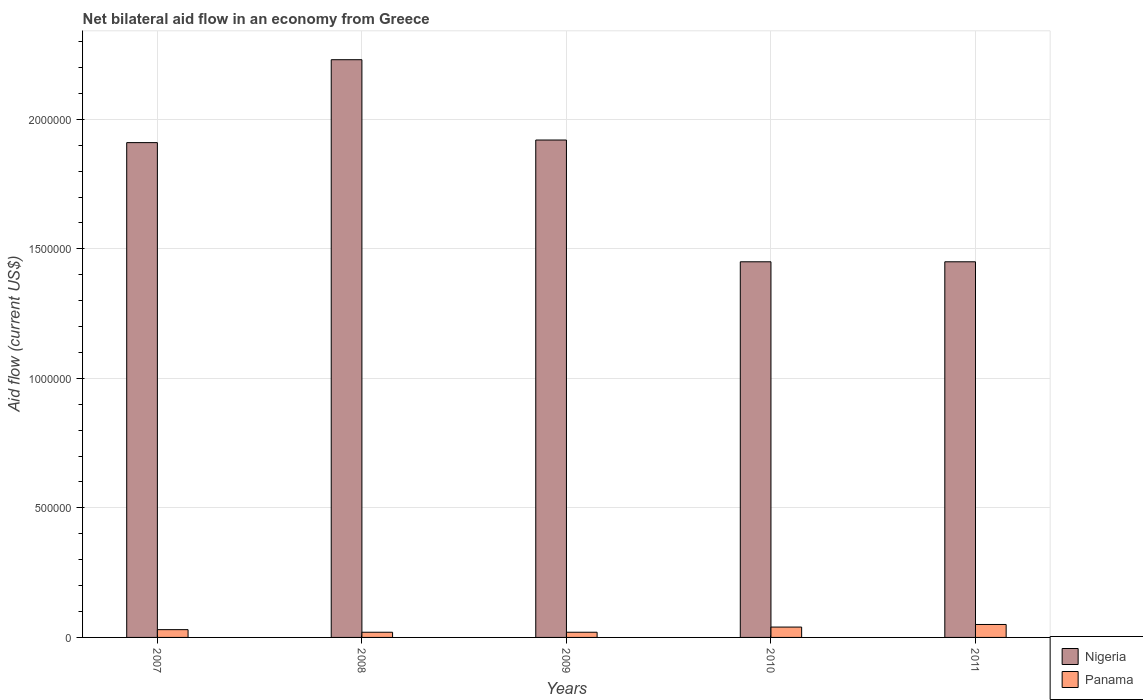How many different coloured bars are there?
Offer a very short reply. 2. How many groups of bars are there?
Keep it short and to the point. 5. Are the number of bars on each tick of the X-axis equal?
Provide a short and direct response. Yes. How many bars are there on the 4th tick from the right?
Your response must be concise. 2. What is the net bilateral aid flow in Nigeria in 2010?
Your response must be concise. 1.45e+06. Across all years, what is the maximum net bilateral aid flow in Panama?
Provide a short and direct response. 5.00e+04. Across all years, what is the minimum net bilateral aid flow in Nigeria?
Provide a short and direct response. 1.45e+06. What is the total net bilateral aid flow in Nigeria in the graph?
Keep it short and to the point. 8.96e+06. What is the difference between the net bilateral aid flow in Nigeria in 2007 and the net bilateral aid flow in Panama in 2009?
Make the answer very short. 1.89e+06. What is the average net bilateral aid flow in Nigeria per year?
Your answer should be very brief. 1.79e+06. In the year 2008, what is the difference between the net bilateral aid flow in Panama and net bilateral aid flow in Nigeria?
Make the answer very short. -2.21e+06. What is the ratio of the net bilateral aid flow in Nigeria in 2008 to that in 2009?
Provide a succinct answer. 1.16. Is the difference between the net bilateral aid flow in Panama in 2007 and 2008 greater than the difference between the net bilateral aid flow in Nigeria in 2007 and 2008?
Ensure brevity in your answer.  Yes. What is the difference between the highest and the second highest net bilateral aid flow in Panama?
Provide a short and direct response. 10000. Is the sum of the net bilateral aid flow in Panama in 2009 and 2011 greater than the maximum net bilateral aid flow in Nigeria across all years?
Offer a terse response. No. What does the 2nd bar from the left in 2007 represents?
Offer a very short reply. Panama. What does the 1st bar from the right in 2011 represents?
Provide a short and direct response. Panama. Are all the bars in the graph horizontal?
Provide a succinct answer. No. What is the difference between two consecutive major ticks on the Y-axis?
Make the answer very short. 5.00e+05. Are the values on the major ticks of Y-axis written in scientific E-notation?
Your answer should be compact. No. Where does the legend appear in the graph?
Your answer should be compact. Bottom right. How many legend labels are there?
Your response must be concise. 2. How are the legend labels stacked?
Keep it short and to the point. Vertical. What is the title of the graph?
Provide a succinct answer. Net bilateral aid flow in an economy from Greece. What is the label or title of the Y-axis?
Make the answer very short. Aid flow (current US$). What is the Aid flow (current US$) in Nigeria in 2007?
Your answer should be compact. 1.91e+06. What is the Aid flow (current US$) of Nigeria in 2008?
Offer a very short reply. 2.23e+06. What is the Aid flow (current US$) in Nigeria in 2009?
Keep it short and to the point. 1.92e+06. What is the Aid flow (current US$) in Nigeria in 2010?
Provide a succinct answer. 1.45e+06. What is the Aid flow (current US$) of Nigeria in 2011?
Your response must be concise. 1.45e+06. Across all years, what is the maximum Aid flow (current US$) in Nigeria?
Give a very brief answer. 2.23e+06. Across all years, what is the maximum Aid flow (current US$) in Panama?
Your answer should be compact. 5.00e+04. Across all years, what is the minimum Aid flow (current US$) in Nigeria?
Make the answer very short. 1.45e+06. Across all years, what is the minimum Aid flow (current US$) in Panama?
Offer a terse response. 2.00e+04. What is the total Aid flow (current US$) in Nigeria in the graph?
Keep it short and to the point. 8.96e+06. What is the difference between the Aid flow (current US$) of Nigeria in 2007 and that in 2008?
Your response must be concise. -3.20e+05. What is the difference between the Aid flow (current US$) of Panama in 2007 and that in 2008?
Provide a short and direct response. 10000. What is the difference between the Aid flow (current US$) in Panama in 2007 and that in 2009?
Offer a terse response. 10000. What is the difference between the Aid flow (current US$) of Nigeria in 2007 and that in 2011?
Provide a short and direct response. 4.60e+05. What is the difference between the Aid flow (current US$) in Panama in 2008 and that in 2009?
Your response must be concise. 0. What is the difference between the Aid flow (current US$) of Nigeria in 2008 and that in 2010?
Your response must be concise. 7.80e+05. What is the difference between the Aid flow (current US$) in Nigeria in 2008 and that in 2011?
Provide a succinct answer. 7.80e+05. What is the difference between the Aid flow (current US$) of Panama in 2008 and that in 2011?
Ensure brevity in your answer.  -3.00e+04. What is the difference between the Aid flow (current US$) in Nigeria in 2009 and that in 2010?
Your answer should be very brief. 4.70e+05. What is the difference between the Aid flow (current US$) of Panama in 2009 and that in 2010?
Keep it short and to the point. -2.00e+04. What is the difference between the Aid flow (current US$) of Nigeria in 2009 and that in 2011?
Keep it short and to the point. 4.70e+05. What is the difference between the Aid flow (current US$) of Nigeria in 2010 and that in 2011?
Give a very brief answer. 0. What is the difference between the Aid flow (current US$) in Nigeria in 2007 and the Aid flow (current US$) in Panama in 2008?
Ensure brevity in your answer.  1.89e+06. What is the difference between the Aid flow (current US$) in Nigeria in 2007 and the Aid flow (current US$) in Panama in 2009?
Your answer should be very brief. 1.89e+06. What is the difference between the Aid flow (current US$) in Nigeria in 2007 and the Aid flow (current US$) in Panama in 2010?
Offer a terse response. 1.87e+06. What is the difference between the Aid flow (current US$) of Nigeria in 2007 and the Aid flow (current US$) of Panama in 2011?
Offer a very short reply. 1.86e+06. What is the difference between the Aid flow (current US$) of Nigeria in 2008 and the Aid flow (current US$) of Panama in 2009?
Provide a succinct answer. 2.21e+06. What is the difference between the Aid flow (current US$) of Nigeria in 2008 and the Aid flow (current US$) of Panama in 2010?
Give a very brief answer. 2.19e+06. What is the difference between the Aid flow (current US$) of Nigeria in 2008 and the Aid flow (current US$) of Panama in 2011?
Your answer should be very brief. 2.18e+06. What is the difference between the Aid flow (current US$) in Nigeria in 2009 and the Aid flow (current US$) in Panama in 2010?
Provide a short and direct response. 1.88e+06. What is the difference between the Aid flow (current US$) of Nigeria in 2009 and the Aid flow (current US$) of Panama in 2011?
Offer a terse response. 1.87e+06. What is the difference between the Aid flow (current US$) of Nigeria in 2010 and the Aid flow (current US$) of Panama in 2011?
Offer a very short reply. 1.40e+06. What is the average Aid flow (current US$) in Nigeria per year?
Ensure brevity in your answer.  1.79e+06. What is the average Aid flow (current US$) in Panama per year?
Keep it short and to the point. 3.20e+04. In the year 2007, what is the difference between the Aid flow (current US$) in Nigeria and Aid flow (current US$) in Panama?
Your answer should be very brief. 1.88e+06. In the year 2008, what is the difference between the Aid flow (current US$) of Nigeria and Aid flow (current US$) of Panama?
Give a very brief answer. 2.21e+06. In the year 2009, what is the difference between the Aid flow (current US$) of Nigeria and Aid flow (current US$) of Panama?
Keep it short and to the point. 1.90e+06. In the year 2010, what is the difference between the Aid flow (current US$) of Nigeria and Aid flow (current US$) of Panama?
Provide a short and direct response. 1.41e+06. In the year 2011, what is the difference between the Aid flow (current US$) of Nigeria and Aid flow (current US$) of Panama?
Your response must be concise. 1.40e+06. What is the ratio of the Aid flow (current US$) of Nigeria in 2007 to that in 2008?
Your answer should be very brief. 0.86. What is the ratio of the Aid flow (current US$) of Nigeria in 2007 to that in 2009?
Offer a very short reply. 0.99. What is the ratio of the Aid flow (current US$) in Panama in 2007 to that in 2009?
Provide a succinct answer. 1.5. What is the ratio of the Aid flow (current US$) in Nigeria in 2007 to that in 2010?
Your response must be concise. 1.32. What is the ratio of the Aid flow (current US$) of Nigeria in 2007 to that in 2011?
Ensure brevity in your answer.  1.32. What is the ratio of the Aid flow (current US$) of Panama in 2007 to that in 2011?
Offer a very short reply. 0.6. What is the ratio of the Aid flow (current US$) of Nigeria in 2008 to that in 2009?
Offer a very short reply. 1.16. What is the ratio of the Aid flow (current US$) in Nigeria in 2008 to that in 2010?
Keep it short and to the point. 1.54. What is the ratio of the Aid flow (current US$) of Nigeria in 2008 to that in 2011?
Keep it short and to the point. 1.54. What is the ratio of the Aid flow (current US$) in Nigeria in 2009 to that in 2010?
Give a very brief answer. 1.32. What is the ratio of the Aid flow (current US$) of Panama in 2009 to that in 2010?
Make the answer very short. 0.5. What is the ratio of the Aid flow (current US$) in Nigeria in 2009 to that in 2011?
Offer a very short reply. 1.32. What is the ratio of the Aid flow (current US$) in Panama in 2010 to that in 2011?
Offer a terse response. 0.8. What is the difference between the highest and the lowest Aid flow (current US$) of Nigeria?
Your answer should be compact. 7.80e+05. 